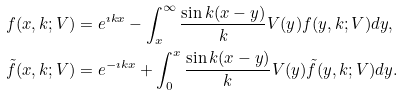<formula> <loc_0><loc_0><loc_500><loc_500>f ( x , k ; V ) & = e ^ { \imath k x } - \int _ { x } ^ { \infty } \frac { \sin k ( x - y ) } { k } V ( y ) f ( y , k ; V ) d y , \\ \tilde { f } ( x , k ; V ) & = e ^ { - \imath k x } + \int _ { 0 } ^ { x } \frac { \sin k ( x - y ) } { k } V ( y ) \tilde { f } ( y , k ; V ) d y .</formula> 